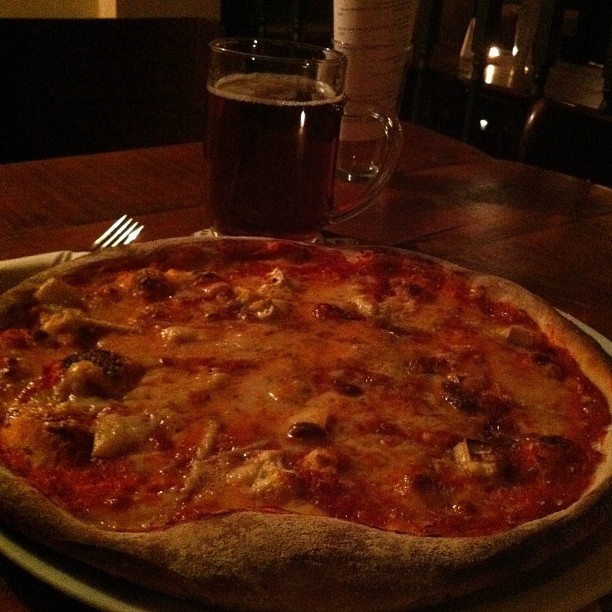Describe the objects in this image and their specific colors. I can see pizza in maroon, black, and brown tones, dining table in maroon, black, and brown tones, cup in maroon, black, and gray tones, and fork in maroon, olive, beige, and tan tones in this image. 